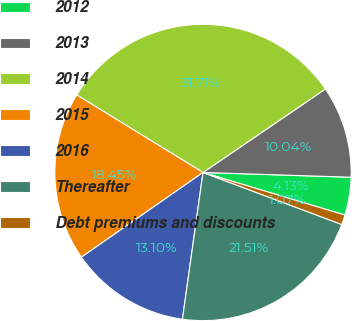Convert chart to OTSL. <chart><loc_0><loc_0><loc_500><loc_500><pie_chart><fcel>2012<fcel>2013<fcel>2014<fcel>2015<fcel>2016<fcel>Thereafter<fcel>Debt premiums and discounts<nl><fcel>4.13%<fcel>10.04%<fcel>31.71%<fcel>18.45%<fcel>13.1%<fcel>21.51%<fcel>1.07%<nl></chart> 